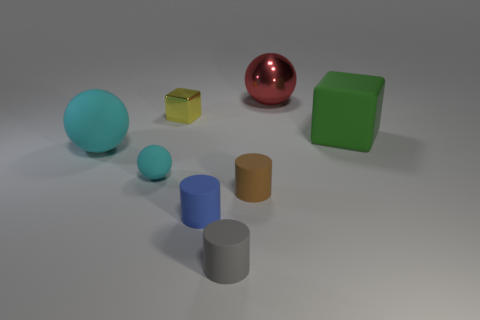Subtract all yellow cylinders. Subtract all brown balls. How many cylinders are left? 3 Add 1 tiny red balls. How many objects exist? 9 Subtract all spheres. How many objects are left? 5 Add 8 small gray cylinders. How many small gray cylinders exist? 9 Subtract 1 yellow cubes. How many objects are left? 7 Subtract all large balls. Subtract all brown rubber objects. How many objects are left? 5 Add 4 brown rubber cylinders. How many brown rubber cylinders are left? 5 